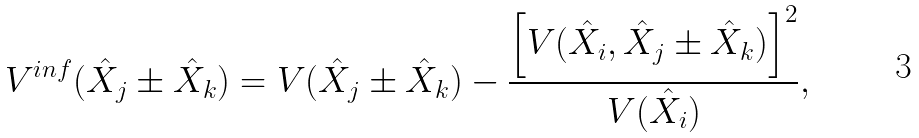Convert formula to latex. <formula><loc_0><loc_0><loc_500><loc_500>V ^ { i n f } ( \hat { X } _ { j } \pm \hat { X } _ { k } ) = V ( \hat { X } _ { j } \pm \hat { X } _ { k } ) - \frac { \left [ V ( \hat { X } _ { i } , \hat { X } _ { j } \pm \hat { X } _ { k } ) \right ] ^ { 2 } } { V ( \hat { X } _ { i } ) } ,</formula> 